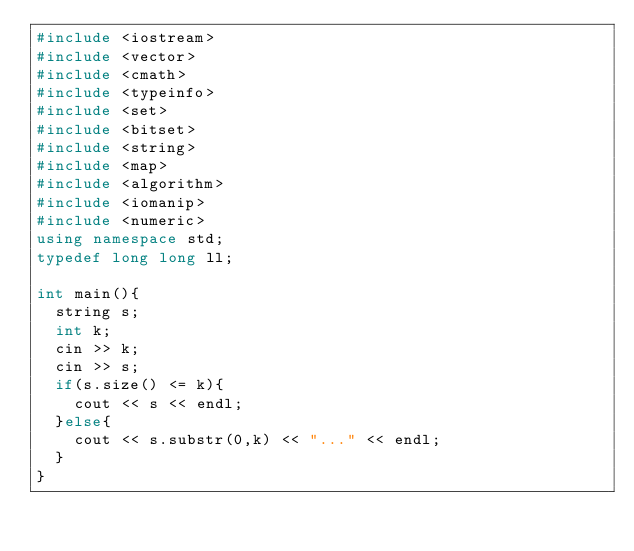Convert code to text. <code><loc_0><loc_0><loc_500><loc_500><_C++_>#include <iostream>
#include <vector>
#include <cmath>
#include <typeinfo>
#include <set>
#include <bitset>
#include <string>
#include <map>
#include <algorithm>
#include <iomanip>
#include <numeric>
using namespace std;
typedef long long ll;

int main(){
  string s;
  int k;
  cin >> k;
  cin >> s;
  if(s.size() <= k){
    cout << s << endl;
  }else{
    cout << s.substr(0,k) << "..." << endl;
  }
} </code> 